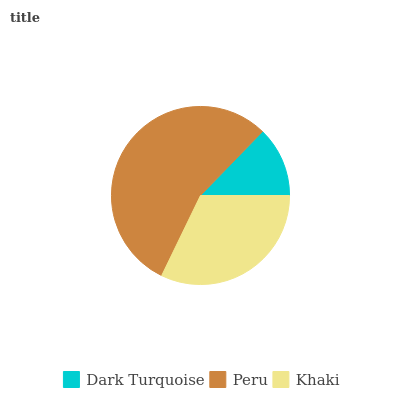Is Dark Turquoise the minimum?
Answer yes or no. Yes. Is Peru the maximum?
Answer yes or no. Yes. Is Khaki the minimum?
Answer yes or no. No. Is Khaki the maximum?
Answer yes or no. No. Is Peru greater than Khaki?
Answer yes or no. Yes. Is Khaki less than Peru?
Answer yes or no. Yes. Is Khaki greater than Peru?
Answer yes or no. No. Is Peru less than Khaki?
Answer yes or no. No. Is Khaki the high median?
Answer yes or no. Yes. Is Khaki the low median?
Answer yes or no. Yes. Is Peru the high median?
Answer yes or no. No. Is Dark Turquoise the low median?
Answer yes or no. No. 